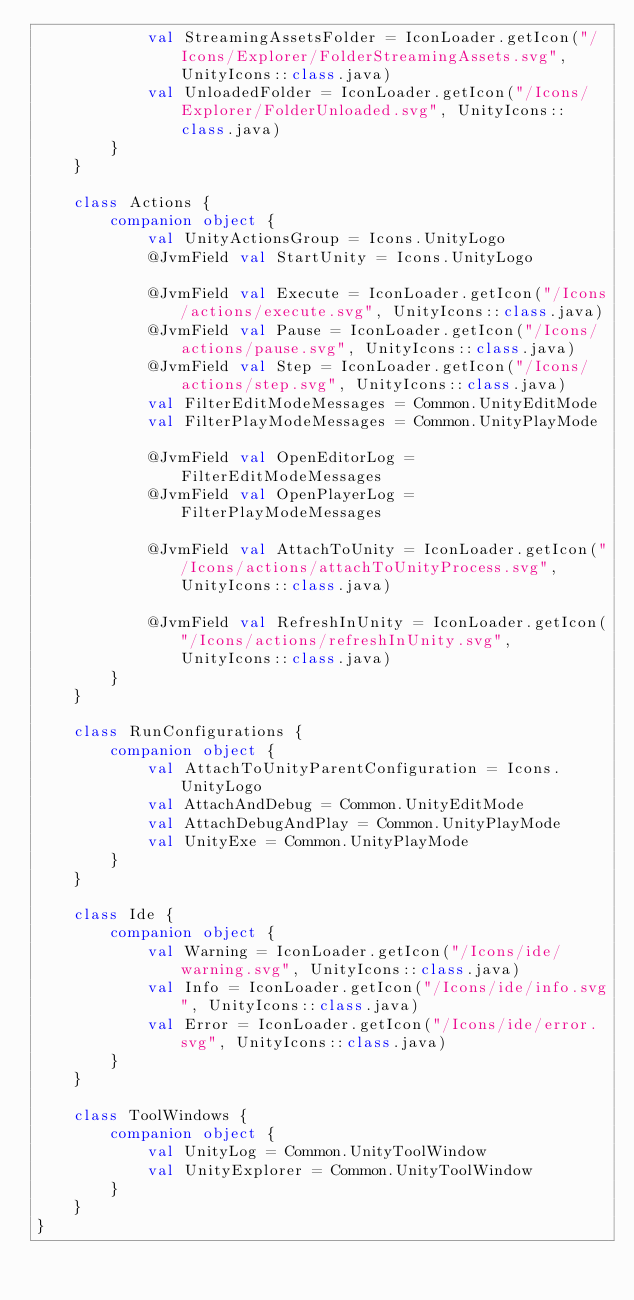<code> <loc_0><loc_0><loc_500><loc_500><_Kotlin_>            val StreamingAssetsFolder = IconLoader.getIcon("/Icons/Explorer/FolderStreamingAssets.svg", UnityIcons::class.java)
            val UnloadedFolder = IconLoader.getIcon("/Icons/Explorer/FolderUnloaded.svg", UnityIcons::class.java)
        }
    }

    class Actions {
        companion object {
            val UnityActionsGroup = Icons.UnityLogo
            @JvmField val StartUnity = Icons.UnityLogo

            @JvmField val Execute = IconLoader.getIcon("/Icons/actions/execute.svg", UnityIcons::class.java)
            @JvmField val Pause = IconLoader.getIcon("/Icons/actions/pause.svg", UnityIcons::class.java)
            @JvmField val Step = IconLoader.getIcon("/Icons/actions/step.svg", UnityIcons::class.java)
            val FilterEditModeMessages = Common.UnityEditMode
            val FilterPlayModeMessages = Common.UnityPlayMode

            @JvmField val OpenEditorLog = FilterEditModeMessages
            @JvmField val OpenPlayerLog = FilterPlayModeMessages

            @JvmField val AttachToUnity = IconLoader.getIcon("/Icons/actions/attachToUnityProcess.svg", UnityIcons::class.java)

            @JvmField val RefreshInUnity = IconLoader.getIcon("/Icons/actions/refreshInUnity.svg", UnityIcons::class.java)
        }
    }

    class RunConfigurations {
        companion object {
            val AttachToUnityParentConfiguration = Icons.UnityLogo
            val AttachAndDebug = Common.UnityEditMode
            val AttachDebugAndPlay = Common.UnityPlayMode
            val UnityExe = Common.UnityPlayMode
        }
    }

    class Ide {
        companion object {
            val Warning = IconLoader.getIcon("/Icons/ide/warning.svg", UnityIcons::class.java)
            val Info = IconLoader.getIcon("/Icons/ide/info.svg", UnityIcons::class.java)
            val Error = IconLoader.getIcon("/Icons/ide/error.svg", UnityIcons::class.java)
        }
    }

    class ToolWindows {
        companion object {
            val UnityLog = Common.UnityToolWindow
            val UnityExplorer = Common.UnityToolWindow
        }
    }
}

</code> 